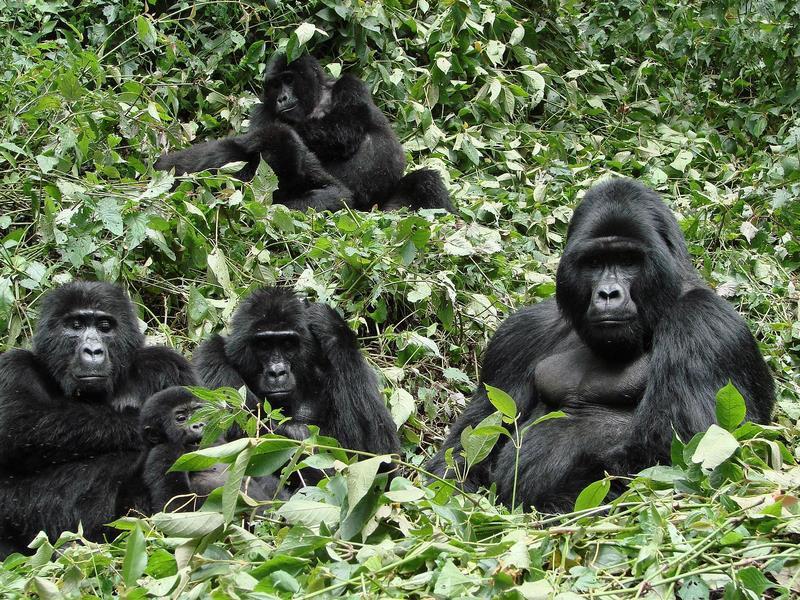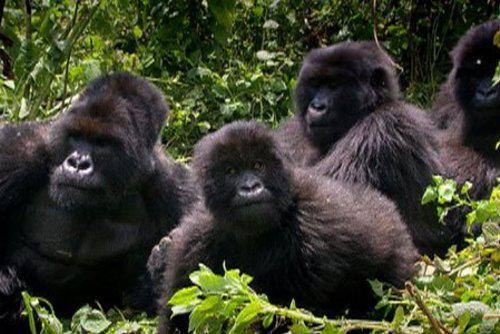The first image is the image on the left, the second image is the image on the right. Analyze the images presented: Is the assertion "An image shows one adult ape, which is touching some part of its head with one hand." valid? Answer yes or no. No. The first image is the image on the left, the second image is the image on the right. Assess this claim about the two images: "At least one of the images contains exactly one gorilla.". Correct or not? Answer yes or no. No. 